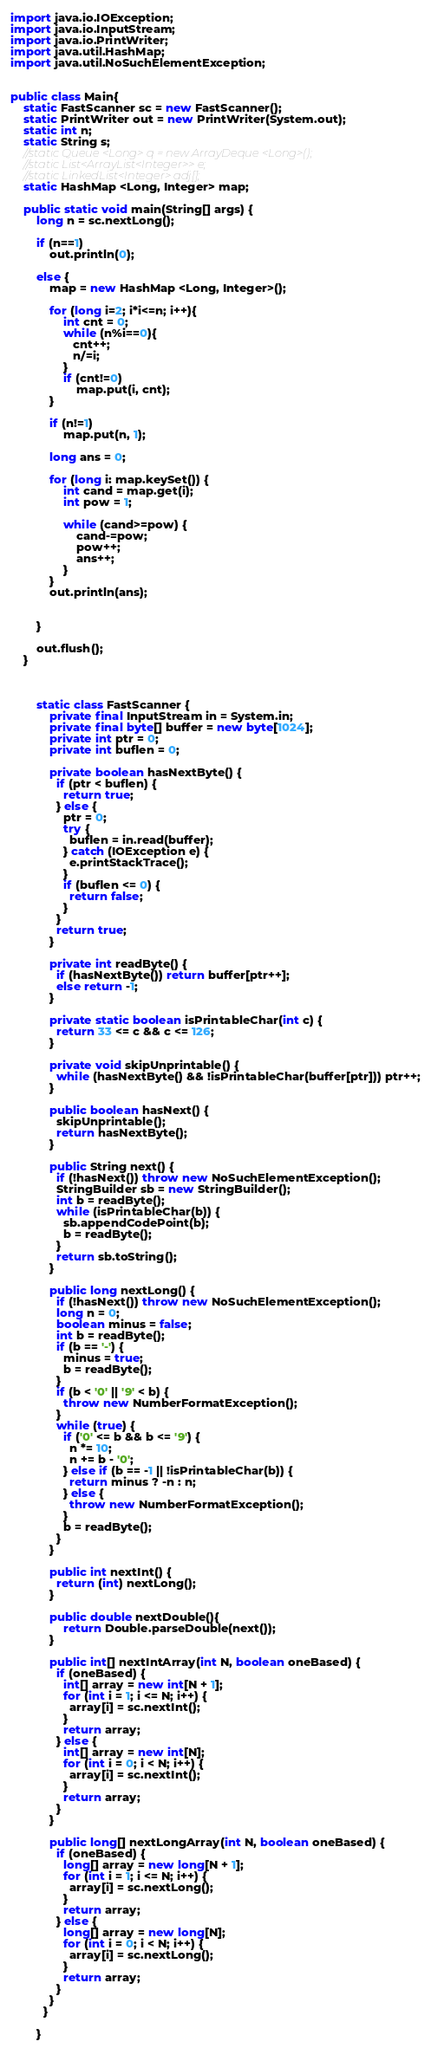<code> <loc_0><loc_0><loc_500><loc_500><_Java_>import java.io.IOException;
import java.io.InputStream;
import java.io.PrintWriter;
import java.util.HashMap;
import java.util.NoSuchElementException;


public class Main{
	static FastScanner sc = new FastScanner();
	static PrintWriter out = new PrintWriter(System.out);
	static int n;
	static String s;
	//static Queue <Long> q = new ArrayDeque <Long>();
	//static List<ArrayList<Integer>> e;
	//static LinkedList<Integer> adj[]; 
	static HashMap <Long, Integer> map;

	public static void main(String[] args) {
		long n = sc.nextLong();
		
		if (n==1)
			out.println(0);
		
		else {
			map = new HashMap <Long, Integer>();
			
			for (long i=2; i*i<=n; i++){
				int cnt = 0;
	            while (n%i==0){
	               cnt++;
	               n/=i;
	            }
	            if (cnt!=0)
	            	map.put(i, cnt);
	        }
			
			if (n!=1)
				map.put(n, 1);
			
			long ans = 0;
			
			for (long i: map.keySet()) {
				int cand = map.get(i);
				int pow = 1;
				
				while (cand>=pow) {
					cand-=pow;
					pow++;
					ans++;
				}
			}
			out.println(ans);
				
			
		}
		
		out.flush();
	}
	
	
	
		static class FastScanner {
		    private final InputStream in = System.in;
		    private final byte[] buffer = new byte[1024];
		    private int ptr = 0;
		    private int buflen = 0;

		    private boolean hasNextByte() {
		      if (ptr < buflen) {
		        return true;
		      } else {
		        ptr = 0;
		        try {
		          buflen = in.read(buffer);
		        } catch (IOException e) {
		          e.printStackTrace();
		        }
		        if (buflen <= 0) {
		          return false;
		        }
		      }
		      return true;
		    }

		    private int readByte() {
		      if (hasNextByte()) return buffer[ptr++];
		      else return -1;
		    }

		    private static boolean isPrintableChar(int c) {
		      return 33 <= c && c <= 126;
		    }

		    private void skipUnprintable() {
		      while (hasNextByte() && !isPrintableChar(buffer[ptr])) ptr++;
		    }

		    public boolean hasNext() {
		      skipUnprintable();
		      return hasNextByte();
		    }

		    public String next() {
		      if (!hasNext()) throw new NoSuchElementException();
		      StringBuilder sb = new StringBuilder();
		      int b = readByte();
		      while (isPrintableChar(b)) {
		        sb.appendCodePoint(b);
		        b = readByte();
		      }
		      return sb.toString();
		    }

		    public long nextLong() {
		      if (!hasNext()) throw new NoSuchElementException();
		      long n = 0;
		      boolean minus = false;
		      int b = readByte();
		      if (b == '-') {
		        minus = true;
		        b = readByte();
		      }
		      if (b < '0' || '9' < b) {
		        throw new NumberFormatException();
		      }
		      while (true) {
		        if ('0' <= b && b <= '9') {
		          n *= 10;
		          n += b - '0';
		        } else if (b == -1 || !isPrintableChar(b)) {
		          return minus ? -n : n;
		        } else {
		          throw new NumberFormatException();
		        }
		        b = readByte();
		      }
		    }

		    public int nextInt() {
		      return (int) nextLong();
		    }
		    
		    public double nextDouble(){
		    	return Double.parseDouble(next());
		    }

		    public int[] nextIntArray(int N, boolean oneBased) {
		      if (oneBased) {
		        int[] array = new int[N + 1];
		        for (int i = 1; i <= N; i++) {
		          array[i] = sc.nextInt();
		        }
		        return array;
		      } else {
		        int[] array = new int[N];
		        for (int i = 0; i < N; i++) {
		          array[i] = sc.nextInt();
		        }
		        return array;
		      }
		    }

		    public long[] nextLongArray(int N, boolean oneBased) {
		      if (oneBased) {
		        long[] array = new long[N + 1];
		        for (int i = 1; i <= N; i++) {
		          array[i] = sc.nextLong();
		        }
		        return array;
		      } else {
		        long[] array = new long[N];
		        for (int i = 0; i < N; i++) {
		          array[i] = sc.nextLong();
		        }
		        return array;
		      }
		    }
		  }

		}	 



</code> 